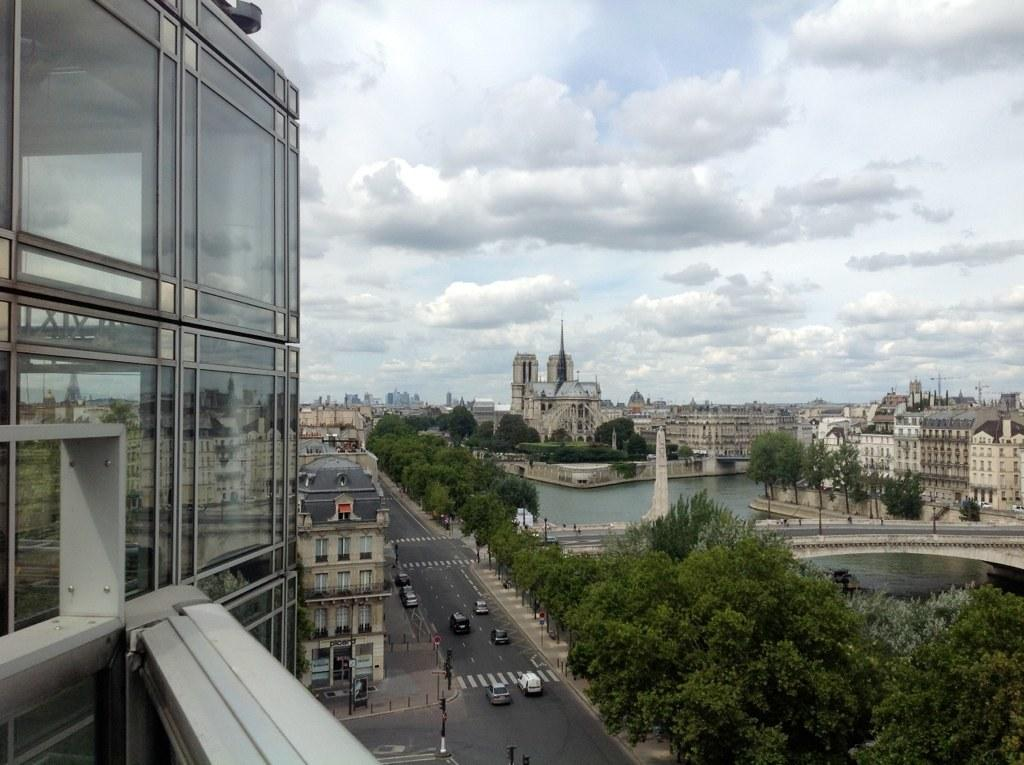What can be seen on the road in the image? There are vehicles on the road in the image. What is the tall, vertical object in the image? There is a pole in the image. What type of natural elements are present in the image? There are trees in the image. What is visible in the background of the image? The background of the image includes water, buildings, a bridge, and the sky. What is the condition of the sky in the image? The sky is visible in the background, and clouds are present in the sky. What type of tongue can be seen licking the pole in the image? There is no tongue present in the image, and therefore no such activity can be observed. What type of debt is being discussed by the vehicles on the road in the image? There is no discussion of debt in the image, as it features vehicles on the road and other elements. What type of milk is being poured into the water in the background of the image? There is no milk present in the image, and therefore no such activity can be observed. 